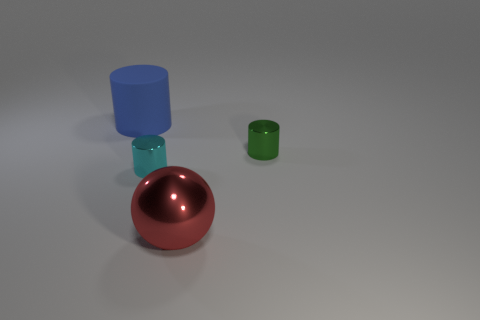Add 1 small cyan objects. How many objects exist? 5 Subtract all cylinders. How many objects are left? 1 Add 4 large metal balls. How many large metal balls exist? 5 Subtract 0 purple cylinders. How many objects are left? 4 Subtract all green metal cylinders. Subtract all big purple objects. How many objects are left? 3 Add 1 big blue things. How many big blue things are left? 2 